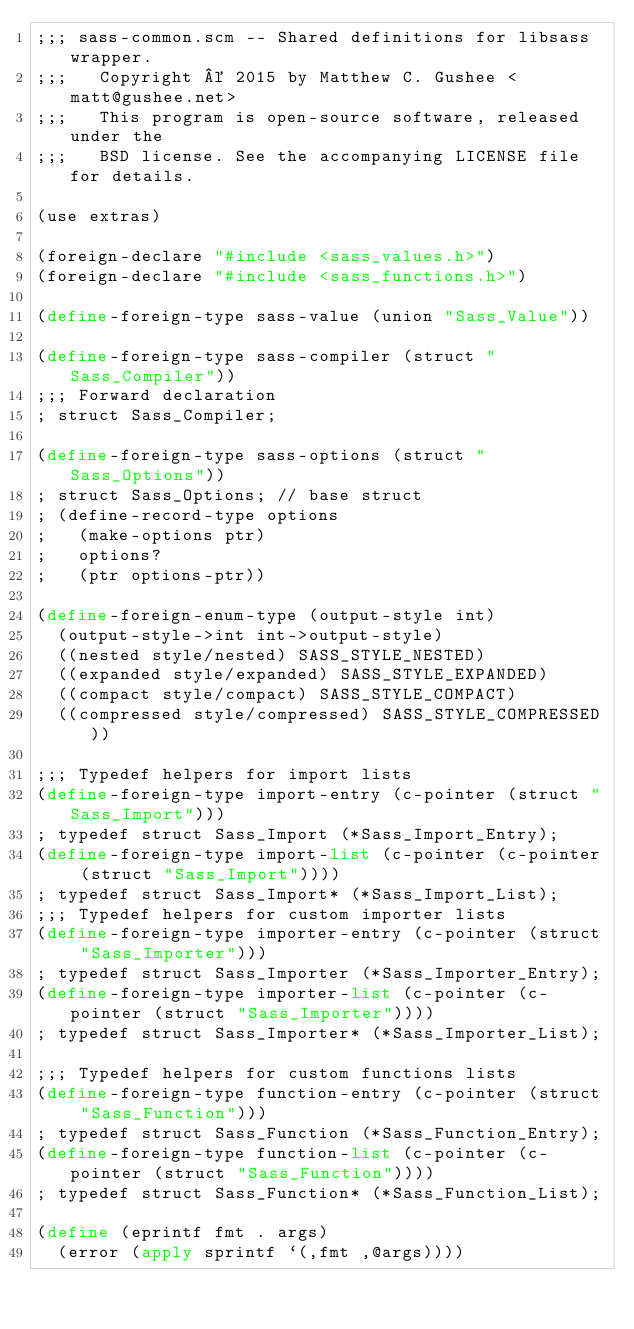Convert code to text. <code><loc_0><loc_0><loc_500><loc_500><_Scheme_>;;; sass-common.scm -- Shared definitions for libsass wrapper.
;;;   Copyright © 2015 by Matthew C. Gushee <matt@gushee.net>
;;;   This program is open-source software, released under the
;;;   BSD license. See the accompanying LICENSE file for details.

(use extras)

(foreign-declare "#include <sass_values.h>")
(foreign-declare "#include <sass_functions.h>")

(define-foreign-type sass-value (union "Sass_Value"))

(define-foreign-type sass-compiler (struct "Sass_Compiler"))
;;; Forward declaration
; struct Sass_Compiler;

(define-foreign-type sass-options (struct "Sass_Options"))
; struct Sass_Options; // base struct
; (define-record-type options
;   (make-options ptr)
;   options?
;   (ptr options-ptr))

(define-foreign-enum-type (output-style int)
  (output-style->int int->output-style)
  ((nested style/nested) SASS_STYLE_NESTED)
  ((expanded style/expanded) SASS_STYLE_EXPANDED)
  ((compact style/compact) SASS_STYLE_COMPACT)
  ((compressed style/compressed) SASS_STYLE_COMPRESSED))

;;; Typedef helpers for import lists
(define-foreign-type import-entry (c-pointer (struct "Sass_Import")))
; typedef struct Sass_Import (*Sass_Import_Entry);
(define-foreign-type import-list (c-pointer (c-pointer (struct "Sass_Import"))))
; typedef struct Sass_Import* (*Sass_Import_List);
;;; Typedef helpers for custom importer lists
(define-foreign-type importer-entry (c-pointer (struct "Sass_Importer")))
; typedef struct Sass_Importer (*Sass_Importer_Entry);
(define-foreign-type importer-list (c-pointer (c-pointer (struct "Sass_Importer"))))
; typedef struct Sass_Importer* (*Sass_Importer_List);

;;; Typedef helpers for custom functions lists
(define-foreign-type function-entry (c-pointer (struct "Sass_Function")))
; typedef struct Sass_Function (*Sass_Function_Entry);
(define-foreign-type function-list (c-pointer (c-pointer (struct "Sass_Function"))))
; typedef struct Sass_Function* (*Sass_Function_List);

(define (eprintf fmt . args)
  (error (apply sprintf `(,fmt ,@args))))
</code> 